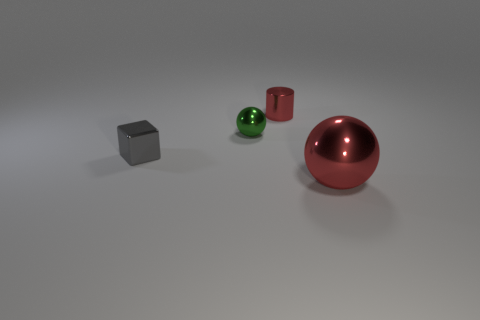Is there a green matte cube that has the same size as the red metal cylinder?
Your answer should be very brief. No. Is the shape of the big red object the same as the red object that is behind the small cube?
Your answer should be very brief. No. How many blocks are tiny metallic objects or tiny green metal objects?
Keep it short and to the point. 1. What color is the small block?
Offer a terse response. Gray. Are there more gray things than small brown matte spheres?
Your answer should be very brief. Yes. How many things are shiny balls left of the shiny cylinder or small metal balls?
Make the answer very short. 1. Is the small red cylinder made of the same material as the tiny cube?
Offer a very short reply. Yes. There is another object that is the same shape as the small green thing; what is its size?
Ensure brevity in your answer.  Large. Does the object that is to the right of the small red cylinder have the same shape as the green object that is on the right side of the gray block?
Make the answer very short. Yes. Do the gray shiny block and the shiny thing that is in front of the gray cube have the same size?
Your answer should be compact. No. 